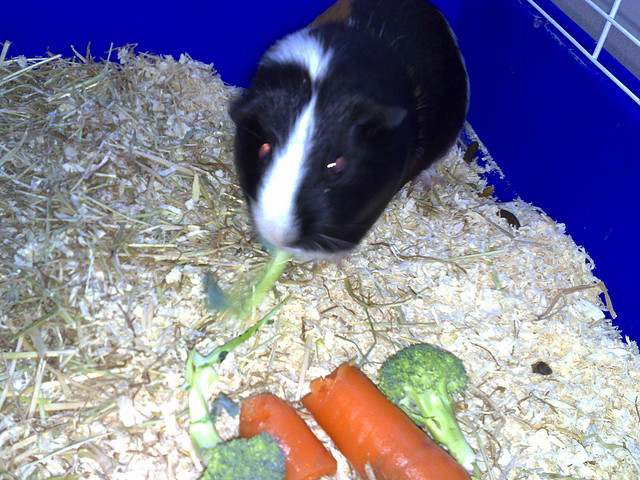How many broccolis can you see? I can see two broccolis in the image. They are accompanied by what appears to be two carrots as well, and there's a guinea pig interacting with one of the broccolis. 